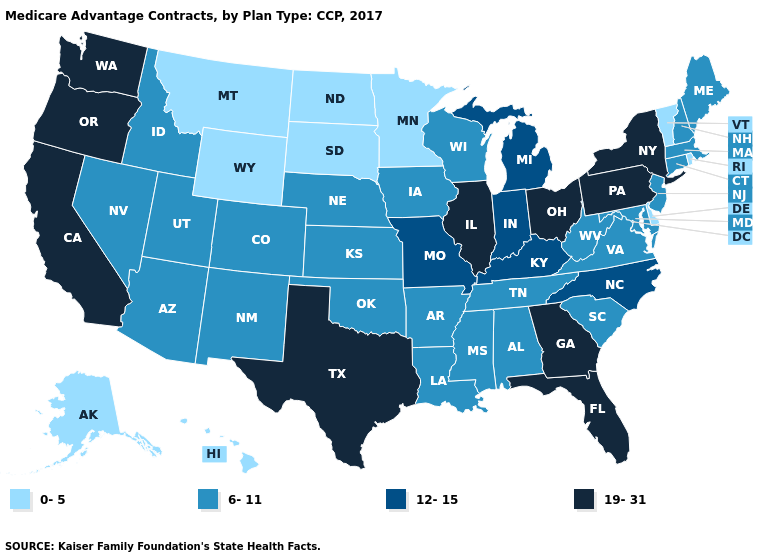Does Rhode Island have the highest value in the USA?
Write a very short answer. No. What is the lowest value in the USA?
Quick response, please. 0-5. Does Iowa have a higher value than Oklahoma?
Answer briefly. No. What is the value of New Mexico?
Be succinct. 6-11. Name the states that have a value in the range 12-15?
Give a very brief answer. Indiana, Kentucky, Michigan, Missouri, North Carolina. What is the highest value in the USA?
Be succinct. 19-31. What is the value of Massachusetts?
Quick response, please. 6-11. Among the states that border Pennsylvania , does Delaware have the lowest value?
Write a very short answer. Yes. Name the states that have a value in the range 12-15?
Write a very short answer. Indiana, Kentucky, Michigan, Missouri, North Carolina. Name the states that have a value in the range 6-11?
Concise answer only. Alabama, Arkansas, Arizona, Colorado, Connecticut, Iowa, Idaho, Kansas, Louisiana, Massachusetts, Maryland, Maine, Mississippi, Nebraska, New Hampshire, New Jersey, New Mexico, Nevada, Oklahoma, South Carolina, Tennessee, Utah, Virginia, Wisconsin, West Virginia. What is the lowest value in the USA?
Write a very short answer. 0-5. Which states have the lowest value in the MidWest?
Concise answer only. Minnesota, North Dakota, South Dakota. Which states hav the highest value in the South?
Answer briefly. Florida, Georgia, Texas. Does the first symbol in the legend represent the smallest category?
Write a very short answer. Yes. Name the states that have a value in the range 6-11?
Be succinct. Alabama, Arkansas, Arizona, Colorado, Connecticut, Iowa, Idaho, Kansas, Louisiana, Massachusetts, Maryland, Maine, Mississippi, Nebraska, New Hampshire, New Jersey, New Mexico, Nevada, Oklahoma, South Carolina, Tennessee, Utah, Virginia, Wisconsin, West Virginia. 